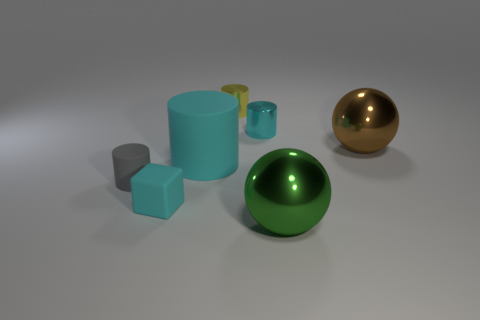Subtract all blue balls. How many cyan cylinders are left? 2 Subtract all gray cylinders. How many cylinders are left? 3 Add 1 blue shiny blocks. How many objects exist? 8 Subtract all green cylinders. Subtract all gray balls. How many cylinders are left? 4 Subtract all balls. How many objects are left? 5 Subtract 0 cyan spheres. How many objects are left? 7 Subtract all large shiny balls. Subtract all small yellow cylinders. How many objects are left? 4 Add 7 metallic cylinders. How many metallic cylinders are left? 9 Add 4 large cyan things. How many large cyan things exist? 5 